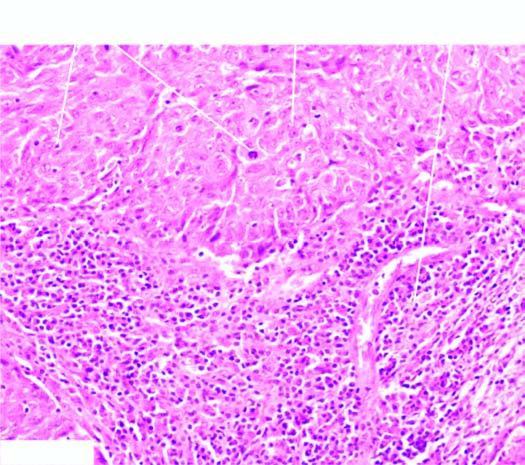what are infiltrated richly with lymphocytes?
Answer the question using a single word or phrase. Stroma 